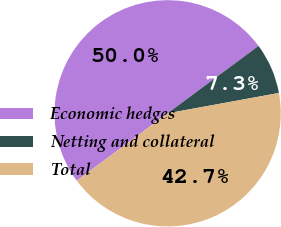Convert chart. <chart><loc_0><loc_0><loc_500><loc_500><pie_chart><fcel>Economic hedges<fcel>Netting and collateral<fcel>Total<nl><fcel>50.0%<fcel>7.28%<fcel>42.72%<nl></chart> 